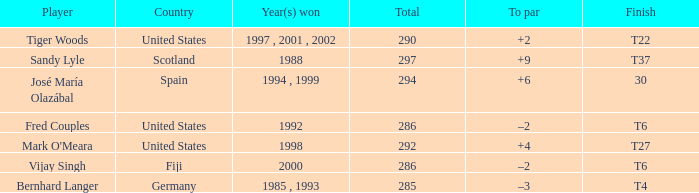Write the full table. {'header': ['Player', 'Country', 'Year(s) won', 'Total', 'To par', 'Finish'], 'rows': [['Tiger Woods', 'United States', '1997 , 2001 , 2002', '290', '+2', 'T22'], ['Sandy Lyle', 'Scotland', '1988', '297', '+9', 'T37'], ['José María Olazábal', 'Spain', '1994 , 1999', '294', '+6', '30'], ['Fred Couples', 'United States', '1992', '286', '–2', 'T6'], ["Mark O'Meara", 'United States', '1998', '292', '+4', 'T27'], ['Vijay Singh', 'Fiji', '2000', '286', '–2', 'T6'], ['Bernhard Langer', 'Germany', '1985 , 1993', '285', '–3', 'T4']]} Which country has a finish of t22? United States. 